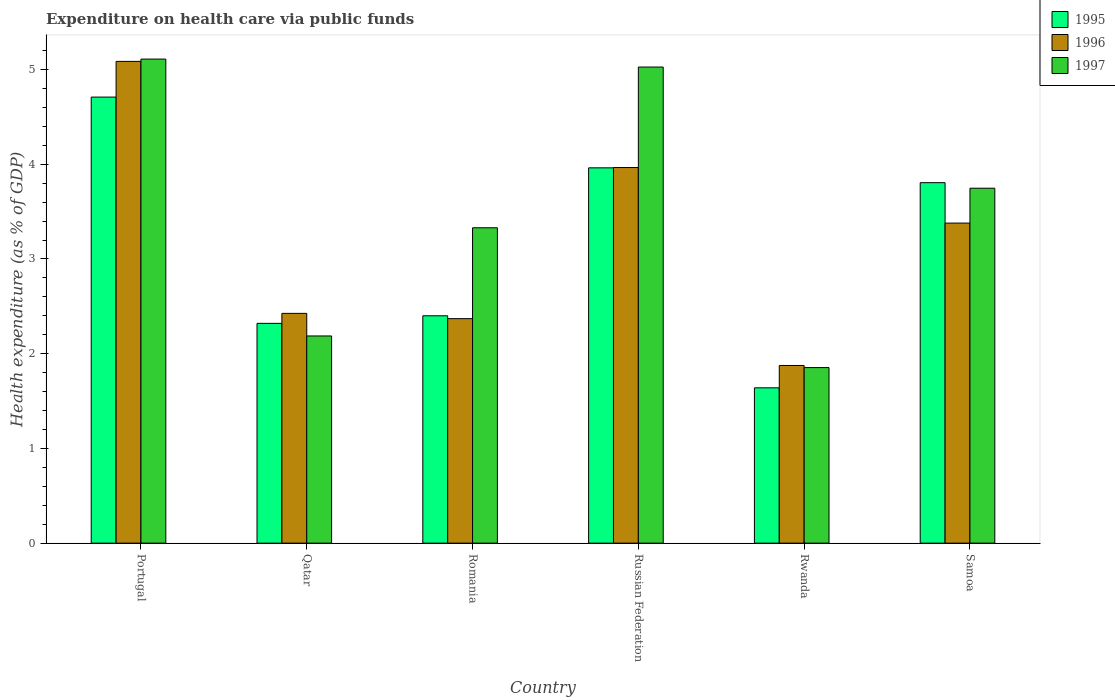How many different coloured bars are there?
Keep it short and to the point. 3. How many groups of bars are there?
Make the answer very short. 6. Are the number of bars on each tick of the X-axis equal?
Keep it short and to the point. Yes. What is the label of the 3rd group of bars from the left?
Offer a terse response. Romania. In how many cases, is the number of bars for a given country not equal to the number of legend labels?
Make the answer very short. 0. What is the expenditure made on health care in 1995 in Portugal?
Give a very brief answer. 4.71. Across all countries, what is the maximum expenditure made on health care in 1996?
Offer a very short reply. 5.09. Across all countries, what is the minimum expenditure made on health care in 1997?
Give a very brief answer. 1.85. In which country was the expenditure made on health care in 1997 maximum?
Your answer should be very brief. Portugal. In which country was the expenditure made on health care in 1997 minimum?
Your response must be concise. Rwanda. What is the total expenditure made on health care in 1997 in the graph?
Your answer should be compact. 21.25. What is the difference between the expenditure made on health care in 1996 in Portugal and that in Romania?
Keep it short and to the point. 2.72. What is the difference between the expenditure made on health care in 1997 in Samoa and the expenditure made on health care in 1995 in Qatar?
Offer a very short reply. 1.43. What is the average expenditure made on health care in 1997 per country?
Make the answer very short. 3.54. What is the difference between the expenditure made on health care of/in 1997 and expenditure made on health care of/in 1995 in Qatar?
Keep it short and to the point. -0.13. What is the ratio of the expenditure made on health care in 1996 in Russian Federation to that in Rwanda?
Your answer should be compact. 2.11. Is the expenditure made on health care in 1997 in Russian Federation less than that in Samoa?
Make the answer very short. No. Is the difference between the expenditure made on health care in 1997 in Russian Federation and Samoa greater than the difference between the expenditure made on health care in 1995 in Russian Federation and Samoa?
Ensure brevity in your answer.  Yes. What is the difference between the highest and the second highest expenditure made on health care in 1996?
Keep it short and to the point. -0.59. What is the difference between the highest and the lowest expenditure made on health care in 1997?
Keep it short and to the point. 3.26. In how many countries, is the expenditure made on health care in 1996 greater than the average expenditure made on health care in 1996 taken over all countries?
Your answer should be compact. 3. What does the 1st bar from the right in Samoa represents?
Your answer should be compact. 1997. How many countries are there in the graph?
Your response must be concise. 6. What is the difference between two consecutive major ticks on the Y-axis?
Keep it short and to the point. 1. Does the graph contain grids?
Your answer should be very brief. No. Where does the legend appear in the graph?
Make the answer very short. Top right. How many legend labels are there?
Offer a terse response. 3. How are the legend labels stacked?
Provide a succinct answer. Vertical. What is the title of the graph?
Provide a succinct answer. Expenditure on health care via public funds. What is the label or title of the X-axis?
Give a very brief answer. Country. What is the label or title of the Y-axis?
Provide a succinct answer. Health expenditure (as % of GDP). What is the Health expenditure (as % of GDP) in 1995 in Portugal?
Your answer should be compact. 4.71. What is the Health expenditure (as % of GDP) of 1996 in Portugal?
Offer a very short reply. 5.09. What is the Health expenditure (as % of GDP) of 1997 in Portugal?
Make the answer very short. 5.11. What is the Health expenditure (as % of GDP) in 1995 in Qatar?
Provide a short and direct response. 2.32. What is the Health expenditure (as % of GDP) of 1996 in Qatar?
Your response must be concise. 2.43. What is the Health expenditure (as % of GDP) in 1997 in Qatar?
Your answer should be compact. 2.19. What is the Health expenditure (as % of GDP) of 1995 in Romania?
Offer a very short reply. 2.4. What is the Health expenditure (as % of GDP) in 1996 in Romania?
Provide a short and direct response. 2.37. What is the Health expenditure (as % of GDP) of 1997 in Romania?
Provide a short and direct response. 3.33. What is the Health expenditure (as % of GDP) of 1995 in Russian Federation?
Make the answer very short. 3.96. What is the Health expenditure (as % of GDP) of 1996 in Russian Federation?
Your response must be concise. 3.97. What is the Health expenditure (as % of GDP) in 1997 in Russian Federation?
Provide a short and direct response. 5.03. What is the Health expenditure (as % of GDP) of 1995 in Rwanda?
Ensure brevity in your answer.  1.64. What is the Health expenditure (as % of GDP) in 1996 in Rwanda?
Provide a short and direct response. 1.88. What is the Health expenditure (as % of GDP) in 1997 in Rwanda?
Offer a very short reply. 1.85. What is the Health expenditure (as % of GDP) in 1995 in Samoa?
Give a very brief answer. 3.81. What is the Health expenditure (as % of GDP) in 1996 in Samoa?
Your response must be concise. 3.38. What is the Health expenditure (as % of GDP) in 1997 in Samoa?
Your answer should be compact. 3.75. Across all countries, what is the maximum Health expenditure (as % of GDP) in 1995?
Give a very brief answer. 4.71. Across all countries, what is the maximum Health expenditure (as % of GDP) in 1996?
Keep it short and to the point. 5.09. Across all countries, what is the maximum Health expenditure (as % of GDP) in 1997?
Provide a short and direct response. 5.11. Across all countries, what is the minimum Health expenditure (as % of GDP) in 1995?
Provide a succinct answer. 1.64. Across all countries, what is the minimum Health expenditure (as % of GDP) in 1996?
Offer a very short reply. 1.88. Across all countries, what is the minimum Health expenditure (as % of GDP) in 1997?
Offer a very short reply. 1.85. What is the total Health expenditure (as % of GDP) of 1995 in the graph?
Provide a short and direct response. 18.84. What is the total Health expenditure (as % of GDP) in 1996 in the graph?
Ensure brevity in your answer.  19.1. What is the total Health expenditure (as % of GDP) in 1997 in the graph?
Your response must be concise. 21.25. What is the difference between the Health expenditure (as % of GDP) in 1995 in Portugal and that in Qatar?
Your answer should be compact. 2.39. What is the difference between the Health expenditure (as % of GDP) of 1996 in Portugal and that in Qatar?
Your answer should be very brief. 2.66. What is the difference between the Health expenditure (as % of GDP) of 1997 in Portugal and that in Qatar?
Provide a short and direct response. 2.92. What is the difference between the Health expenditure (as % of GDP) of 1995 in Portugal and that in Romania?
Offer a terse response. 2.31. What is the difference between the Health expenditure (as % of GDP) in 1996 in Portugal and that in Romania?
Your answer should be very brief. 2.72. What is the difference between the Health expenditure (as % of GDP) in 1997 in Portugal and that in Romania?
Offer a terse response. 1.78. What is the difference between the Health expenditure (as % of GDP) of 1995 in Portugal and that in Russian Federation?
Keep it short and to the point. 0.75. What is the difference between the Health expenditure (as % of GDP) of 1996 in Portugal and that in Russian Federation?
Ensure brevity in your answer.  1.12. What is the difference between the Health expenditure (as % of GDP) in 1997 in Portugal and that in Russian Federation?
Your answer should be very brief. 0.08. What is the difference between the Health expenditure (as % of GDP) of 1995 in Portugal and that in Rwanda?
Give a very brief answer. 3.07. What is the difference between the Health expenditure (as % of GDP) of 1996 in Portugal and that in Rwanda?
Your response must be concise. 3.21. What is the difference between the Health expenditure (as % of GDP) in 1997 in Portugal and that in Rwanda?
Offer a very short reply. 3.26. What is the difference between the Health expenditure (as % of GDP) of 1995 in Portugal and that in Samoa?
Your answer should be very brief. 0.9. What is the difference between the Health expenditure (as % of GDP) in 1996 in Portugal and that in Samoa?
Give a very brief answer. 1.71. What is the difference between the Health expenditure (as % of GDP) of 1997 in Portugal and that in Samoa?
Provide a short and direct response. 1.36. What is the difference between the Health expenditure (as % of GDP) of 1995 in Qatar and that in Romania?
Make the answer very short. -0.08. What is the difference between the Health expenditure (as % of GDP) in 1996 in Qatar and that in Romania?
Provide a short and direct response. 0.06. What is the difference between the Health expenditure (as % of GDP) of 1997 in Qatar and that in Romania?
Your answer should be very brief. -1.14. What is the difference between the Health expenditure (as % of GDP) in 1995 in Qatar and that in Russian Federation?
Keep it short and to the point. -1.64. What is the difference between the Health expenditure (as % of GDP) in 1996 in Qatar and that in Russian Federation?
Provide a succinct answer. -1.54. What is the difference between the Health expenditure (as % of GDP) in 1997 in Qatar and that in Russian Federation?
Keep it short and to the point. -2.84. What is the difference between the Health expenditure (as % of GDP) in 1995 in Qatar and that in Rwanda?
Ensure brevity in your answer.  0.68. What is the difference between the Health expenditure (as % of GDP) in 1996 in Qatar and that in Rwanda?
Make the answer very short. 0.55. What is the difference between the Health expenditure (as % of GDP) of 1997 in Qatar and that in Rwanda?
Provide a short and direct response. 0.33. What is the difference between the Health expenditure (as % of GDP) in 1995 in Qatar and that in Samoa?
Your response must be concise. -1.49. What is the difference between the Health expenditure (as % of GDP) of 1996 in Qatar and that in Samoa?
Provide a succinct answer. -0.95. What is the difference between the Health expenditure (as % of GDP) of 1997 in Qatar and that in Samoa?
Make the answer very short. -1.56. What is the difference between the Health expenditure (as % of GDP) of 1995 in Romania and that in Russian Federation?
Your answer should be very brief. -1.56. What is the difference between the Health expenditure (as % of GDP) of 1996 in Romania and that in Russian Federation?
Keep it short and to the point. -1.6. What is the difference between the Health expenditure (as % of GDP) in 1997 in Romania and that in Russian Federation?
Give a very brief answer. -1.7. What is the difference between the Health expenditure (as % of GDP) in 1995 in Romania and that in Rwanda?
Keep it short and to the point. 0.76. What is the difference between the Health expenditure (as % of GDP) of 1996 in Romania and that in Rwanda?
Provide a short and direct response. 0.49. What is the difference between the Health expenditure (as % of GDP) of 1997 in Romania and that in Rwanda?
Offer a very short reply. 1.48. What is the difference between the Health expenditure (as % of GDP) of 1995 in Romania and that in Samoa?
Make the answer very short. -1.41. What is the difference between the Health expenditure (as % of GDP) in 1996 in Romania and that in Samoa?
Provide a short and direct response. -1.01. What is the difference between the Health expenditure (as % of GDP) of 1997 in Romania and that in Samoa?
Keep it short and to the point. -0.42. What is the difference between the Health expenditure (as % of GDP) in 1995 in Russian Federation and that in Rwanda?
Keep it short and to the point. 2.32. What is the difference between the Health expenditure (as % of GDP) of 1996 in Russian Federation and that in Rwanda?
Your answer should be compact. 2.09. What is the difference between the Health expenditure (as % of GDP) in 1997 in Russian Federation and that in Rwanda?
Keep it short and to the point. 3.17. What is the difference between the Health expenditure (as % of GDP) of 1995 in Russian Federation and that in Samoa?
Make the answer very short. 0.16. What is the difference between the Health expenditure (as % of GDP) in 1996 in Russian Federation and that in Samoa?
Offer a very short reply. 0.59. What is the difference between the Health expenditure (as % of GDP) of 1997 in Russian Federation and that in Samoa?
Make the answer very short. 1.28. What is the difference between the Health expenditure (as % of GDP) of 1995 in Rwanda and that in Samoa?
Keep it short and to the point. -2.17. What is the difference between the Health expenditure (as % of GDP) in 1996 in Rwanda and that in Samoa?
Ensure brevity in your answer.  -1.5. What is the difference between the Health expenditure (as % of GDP) of 1997 in Rwanda and that in Samoa?
Provide a short and direct response. -1.89. What is the difference between the Health expenditure (as % of GDP) in 1995 in Portugal and the Health expenditure (as % of GDP) in 1996 in Qatar?
Keep it short and to the point. 2.28. What is the difference between the Health expenditure (as % of GDP) of 1995 in Portugal and the Health expenditure (as % of GDP) of 1997 in Qatar?
Your answer should be very brief. 2.52. What is the difference between the Health expenditure (as % of GDP) of 1996 in Portugal and the Health expenditure (as % of GDP) of 1997 in Qatar?
Provide a short and direct response. 2.9. What is the difference between the Health expenditure (as % of GDP) in 1995 in Portugal and the Health expenditure (as % of GDP) in 1996 in Romania?
Give a very brief answer. 2.34. What is the difference between the Health expenditure (as % of GDP) of 1995 in Portugal and the Health expenditure (as % of GDP) of 1997 in Romania?
Your response must be concise. 1.38. What is the difference between the Health expenditure (as % of GDP) in 1996 in Portugal and the Health expenditure (as % of GDP) in 1997 in Romania?
Give a very brief answer. 1.76. What is the difference between the Health expenditure (as % of GDP) in 1995 in Portugal and the Health expenditure (as % of GDP) in 1996 in Russian Federation?
Ensure brevity in your answer.  0.74. What is the difference between the Health expenditure (as % of GDP) of 1995 in Portugal and the Health expenditure (as % of GDP) of 1997 in Russian Federation?
Your response must be concise. -0.32. What is the difference between the Health expenditure (as % of GDP) in 1996 in Portugal and the Health expenditure (as % of GDP) in 1997 in Russian Federation?
Make the answer very short. 0.06. What is the difference between the Health expenditure (as % of GDP) in 1995 in Portugal and the Health expenditure (as % of GDP) in 1996 in Rwanda?
Give a very brief answer. 2.83. What is the difference between the Health expenditure (as % of GDP) in 1995 in Portugal and the Health expenditure (as % of GDP) in 1997 in Rwanda?
Offer a very short reply. 2.86. What is the difference between the Health expenditure (as % of GDP) of 1996 in Portugal and the Health expenditure (as % of GDP) of 1997 in Rwanda?
Offer a terse response. 3.23. What is the difference between the Health expenditure (as % of GDP) in 1995 in Portugal and the Health expenditure (as % of GDP) in 1996 in Samoa?
Your answer should be very brief. 1.33. What is the difference between the Health expenditure (as % of GDP) of 1995 in Portugal and the Health expenditure (as % of GDP) of 1997 in Samoa?
Make the answer very short. 0.96. What is the difference between the Health expenditure (as % of GDP) of 1996 in Portugal and the Health expenditure (as % of GDP) of 1997 in Samoa?
Offer a terse response. 1.34. What is the difference between the Health expenditure (as % of GDP) of 1995 in Qatar and the Health expenditure (as % of GDP) of 1996 in Romania?
Ensure brevity in your answer.  -0.05. What is the difference between the Health expenditure (as % of GDP) in 1995 in Qatar and the Health expenditure (as % of GDP) in 1997 in Romania?
Your answer should be very brief. -1.01. What is the difference between the Health expenditure (as % of GDP) in 1996 in Qatar and the Health expenditure (as % of GDP) in 1997 in Romania?
Offer a terse response. -0.9. What is the difference between the Health expenditure (as % of GDP) in 1995 in Qatar and the Health expenditure (as % of GDP) in 1996 in Russian Federation?
Provide a succinct answer. -1.65. What is the difference between the Health expenditure (as % of GDP) of 1995 in Qatar and the Health expenditure (as % of GDP) of 1997 in Russian Federation?
Keep it short and to the point. -2.71. What is the difference between the Health expenditure (as % of GDP) of 1996 in Qatar and the Health expenditure (as % of GDP) of 1997 in Russian Federation?
Offer a very short reply. -2.6. What is the difference between the Health expenditure (as % of GDP) of 1995 in Qatar and the Health expenditure (as % of GDP) of 1996 in Rwanda?
Your answer should be compact. 0.44. What is the difference between the Health expenditure (as % of GDP) of 1995 in Qatar and the Health expenditure (as % of GDP) of 1997 in Rwanda?
Offer a terse response. 0.47. What is the difference between the Health expenditure (as % of GDP) in 1996 in Qatar and the Health expenditure (as % of GDP) in 1997 in Rwanda?
Offer a terse response. 0.57. What is the difference between the Health expenditure (as % of GDP) of 1995 in Qatar and the Health expenditure (as % of GDP) of 1996 in Samoa?
Your answer should be very brief. -1.06. What is the difference between the Health expenditure (as % of GDP) in 1995 in Qatar and the Health expenditure (as % of GDP) in 1997 in Samoa?
Offer a terse response. -1.43. What is the difference between the Health expenditure (as % of GDP) of 1996 in Qatar and the Health expenditure (as % of GDP) of 1997 in Samoa?
Offer a very short reply. -1.32. What is the difference between the Health expenditure (as % of GDP) in 1995 in Romania and the Health expenditure (as % of GDP) in 1996 in Russian Federation?
Offer a very short reply. -1.57. What is the difference between the Health expenditure (as % of GDP) in 1995 in Romania and the Health expenditure (as % of GDP) in 1997 in Russian Federation?
Ensure brevity in your answer.  -2.63. What is the difference between the Health expenditure (as % of GDP) in 1996 in Romania and the Health expenditure (as % of GDP) in 1997 in Russian Federation?
Make the answer very short. -2.66. What is the difference between the Health expenditure (as % of GDP) of 1995 in Romania and the Health expenditure (as % of GDP) of 1996 in Rwanda?
Your answer should be compact. 0.52. What is the difference between the Health expenditure (as % of GDP) in 1995 in Romania and the Health expenditure (as % of GDP) in 1997 in Rwanda?
Your answer should be compact. 0.55. What is the difference between the Health expenditure (as % of GDP) in 1996 in Romania and the Health expenditure (as % of GDP) in 1997 in Rwanda?
Your answer should be compact. 0.52. What is the difference between the Health expenditure (as % of GDP) of 1995 in Romania and the Health expenditure (as % of GDP) of 1996 in Samoa?
Give a very brief answer. -0.98. What is the difference between the Health expenditure (as % of GDP) of 1995 in Romania and the Health expenditure (as % of GDP) of 1997 in Samoa?
Ensure brevity in your answer.  -1.35. What is the difference between the Health expenditure (as % of GDP) of 1996 in Romania and the Health expenditure (as % of GDP) of 1997 in Samoa?
Provide a short and direct response. -1.38. What is the difference between the Health expenditure (as % of GDP) of 1995 in Russian Federation and the Health expenditure (as % of GDP) of 1996 in Rwanda?
Give a very brief answer. 2.09. What is the difference between the Health expenditure (as % of GDP) of 1995 in Russian Federation and the Health expenditure (as % of GDP) of 1997 in Rwanda?
Your answer should be very brief. 2.11. What is the difference between the Health expenditure (as % of GDP) in 1996 in Russian Federation and the Health expenditure (as % of GDP) in 1997 in Rwanda?
Make the answer very short. 2.11. What is the difference between the Health expenditure (as % of GDP) of 1995 in Russian Federation and the Health expenditure (as % of GDP) of 1996 in Samoa?
Offer a very short reply. 0.58. What is the difference between the Health expenditure (as % of GDP) in 1995 in Russian Federation and the Health expenditure (as % of GDP) in 1997 in Samoa?
Offer a terse response. 0.21. What is the difference between the Health expenditure (as % of GDP) in 1996 in Russian Federation and the Health expenditure (as % of GDP) in 1997 in Samoa?
Your response must be concise. 0.22. What is the difference between the Health expenditure (as % of GDP) of 1995 in Rwanda and the Health expenditure (as % of GDP) of 1996 in Samoa?
Keep it short and to the point. -1.74. What is the difference between the Health expenditure (as % of GDP) in 1995 in Rwanda and the Health expenditure (as % of GDP) in 1997 in Samoa?
Your response must be concise. -2.11. What is the difference between the Health expenditure (as % of GDP) of 1996 in Rwanda and the Health expenditure (as % of GDP) of 1997 in Samoa?
Keep it short and to the point. -1.87. What is the average Health expenditure (as % of GDP) of 1995 per country?
Offer a terse response. 3.14. What is the average Health expenditure (as % of GDP) of 1996 per country?
Your answer should be very brief. 3.18. What is the average Health expenditure (as % of GDP) in 1997 per country?
Offer a terse response. 3.54. What is the difference between the Health expenditure (as % of GDP) of 1995 and Health expenditure (as % of GDP) of 1996 in Portugal?
Keep it short and to the point. -0.38. What is the difference between the Health expenditure (as % of GDP) of 1995 and Health expenditure (as % of GDP) of 1997 in Portugal?
Offer a terse response. -0.4. What is the difference between the Health expenditure (as % of GDP) of 1996 and Health expenditure (as % of GDP) of 1997 in Portugal?
Give a very brief answer. -0.02. What is the difference between the Health expenditure (as % of GDP) of 1995 and Health expenditure (as % of GDP) of 1996 in Qatar?
Provide a short and direct response. -0.11. What is the difference between the Health expenditure (as % of GDP) of 1995 and Health expenditure (as % of GDP) of 1997 in Qatar?
Ensure brevity in your answer.  0.13. What is the difference between the Health expenditure (as % of GDP) in 1996 and Health expenditure (as % of GDP) in 1997 in Qatar?
Give a very brief answer. 0.24. What is the difference between the Health expenditure (as % of GDP) of 1995 and Health expenditure (as % of GDP) of 1996 in Romania?
Provide a succinct answer. 0.03. What is the difference between the Health expenditure (as % of GDP) in 1995 and Health expenditure (as % of GDP) in 1997 in Romania?
Ensure brevity in your answer.  -0.93. What is the difference between the Health expenditure (as % of GDP) in 1996 and Health expenditure (as % of GDP) in 1997 in Romania?
Your answer should be compact. -0.96. What is the difference between the Health expenditure (as % of GDP) in 1995 and Health expenditure (as % of GDP) in 1996 in Russian Federation?
Make the answer very short. -0. What is the difference between the Health expenditure (as % of GDP) of 1995 and Health expenditure (as % of GDP) of 1997 in Russian Federation?
Make the answer very short. -1.06. What is the difference between the Health expenditure (as % of GDP) in 1996 and Health expenditure (as % of GDP) in 1997 in Russian Federation?
Provide a succinct answer. -1.06. What is the difference between the Health expenditure (as % of GDP) of 1995 and Health expenditure (as % of GDP) of 1996 in Rwanda?
Your answer should be compact. -0.24. What is the difference between the Health expenditure (as % of GDP) in 1995 and Health expenditure (as % of GDP) in 1997 in Rwanda?
Offer a terse response. -0.21. What is the difference between the Health expenditure (as % of GDP) in 1996 and Health expenditure (as % of GDP) in 1997 in Rwanda?
Provide a short and direct response. 0.02. What is the difference between the Health expenditure (as % of GDP) in 1995 and Health expenditure (as % of GDP) in 1996 in Samoa?
Ensure brevity in your answer.  0.43. What is the difference between the Health expenditure (as % of GDP) of 1995 and Health expenditure (as % of GDP) of 1997 in Samoa?
Make the answer very short. 0.06. What is the difference between the Health expenditure (as % of GDP) in 1996 and Health expenditure (as % of GDP) in 1997 in Samoa?
Make the answer very short. -0.37. What is the ratio of the Health expenditure (as % of GDP) in 1995 in Portugal to that in Qatar?
Give a very brief answer. 2.03. What is the ratio of the Health expenditure (as % of GDP) of 1996 in Portugal to that in Qatar?
Provide a succinct answer. 2.1. What is the ratio of the Health expenditure (as % of GDP) in 1997 in Portugal to that in Qatar?
Your response must be concise. 2.34. What is the ratio of the Health expenditure (as % of GDP) of 1995 in Portugal to that in Romania?
Offer a terse response. 1.96. What is the ratio of the Health expenditure (as % of GDP) of 1996 in Portugal to that in Romania?
Give a very brief answer. 2.15. What is the ratio of the Health expenditure (as % of GDP) of 1997 in Portugal to that in Romania?
Your response must be concise. 1.53. What is the ratio of the Health expenditure (as % of GDP) in 1995 in Portugal to that in Russian Federation?
Ensure brevity in your answer.  1.19. What is the ratio of the Health expenditure (as % of GDP) of 1996 in Portugal to that in Russian Federation?
Your answer should be very brief. 1.28. What is the ratio of the Health expenditure (as % of GDP) of 1997 in Portugal to that in Russian Federation?
Your answer should be very brief. 1.02. What is the ratio of the Health expenditure (as % of GDP) of 1995 in Portugal to that in Rwanda?
Provide a succinct answer. 2.87. What is the ratio of the Health expenditure (as % of GDP) of 1996 in Portugal to that in Rwanda?
Keep it short and to the point. 2.71. What is the ratio of the Health expenditure (as % of GDP) of 1997 in Portugal to that in Rwanda?
Provide a short and direct response. 2.76. What is the ratio of the Health expenditure (as % of GDP) in 1995 in Portugal to that in Samoa?
Provide a short and direct response. 1.24. What is the ratio of the Health expenditure (as % of GDP) in 1996 in Portugal to that in Samoa?
Keep it short and to the point. 1.51. What is the ratio of the Health expenditure (as % of GDP) of 1997 in Portugal to that in Samoa?
Ensure brevity in your answer.  1.36. What is the ratio of the Health expenditure (as % of GDP) of 1995 in Qatar to that in Romania?
Your response must be concise. 0.97. What is the ratio of the Health expenditure (as % of GDP) in 1996 in Qatar to that in Romania?
Your answer should be very brief. 1.02. What is the ratio of the Health expenditure (as % of GDP) in 1997 in Qatar to that in Romania?
Keep it short and to the point. 0.66. What is the ratio of the Health expenditure (as % of GDP) in 1995 in Qatar to that in Russian Federation?
Offer a terse response. 0.59. What is the ratio of the Health expenditure (as % of GDP) of 1996 in Qatar to that in Russian Federation?
Your answer should be compact. 0.61. What is the ratio of the Health expenditure (as % of GDP) in 1997 in Qatar to that in Russian Federation?
Offer a terse response. 0.44. What is the ratio of the Health expenditure (as % of GDP) in 1995 in Qatar to that in Rwanda?
Ensure brevity in your answer.  1.42. What is the ratio of the Health expenditure (as % of GDP) of 1996 in Qatar to that in Rwanda?
Your answer should be very brief. 1.29. What is the ratio of the Health expenditure (as % of GDP) of 1997 in Qatar to that in Rwanda?
Offer a terse response. 1.18. What is the ratio of the Health expenditure (as % of GDP) in 1995 in Qatar to that in Samoa?
Make the answer very short. 0.61. What is the ratio of the Health expenditure (as % of GDP) in 1996 in Qatar to that in Samoa?
Give a very brief answer. 0.72. What is the ratio of the Health expenditure (as % of GDP) of 1997 in Qatar to that in Samoa?
Your answer should be compact. 0.58. What is the ratio of the Health expenditure (as % of GDP) in 1995 in Romania to that in Russian Federation?
Your answer should be very brief. 0.61. What is the ratio of the Health expenditure (as % of GDP) of 1996 in Romania to that in Russian Federation?
Give a very brief answer. 0.6. What is the ratio of the Health expenditure (as % of GDP) of 1997 in Romania to that in Russian Federation?
Make the answer very short. 0.66. What is the ratio of the Health expenditure (as % of GDP) in 1995 in Romania to that in Rwanda?
Provide a succinct answer. 1.46. What is the ratio of the Health expenditure (as % of GDP) of 1996 in Romania to that in Rwanda?
Provide a short and direct response. 1.26. What is the ratio of the Health expenditure (as % of GDP) in 1997 in Romania to that in Rwanda?
Make the answer very short. 1.8. What is the ratio of the Health expenditure (as % of GDP) in 1995 in Romania to that in Samoa?
Your answer should be very brief. 0.63. What is the ratio of the Health expenditure (as % of GDP) of 1996 in Romania to that in Samoa?
Keep it short and to the point. 0.7. What is the ratio of the Health expenditure (as % of GDP) of 1997 in Romania to that in Samoa?
Offer a very short reply. 0.89. What is the ratio of the Health expenditure (as % of GDP) in 1995 in Russian Federation to that in Rwanda?
Your answer should be very brief. 2.42. What is the ratio of the Health expenditure (as % of GDP) in 1996 in Russian Federation to that in Rwanda?
Your answer should be very brief. 2.11. What is the ratio of the Health expenditure (as % of GDP) of 1997 in Russian Federation to that in Rwanda?
Provide a succinct answer. 2.71. What is the ratio of the Health expenditure (as % of GDP) of 1995 in Russian Federation to that in Samoa?
Your answer should be compact. 1.04. What is the ratio of the Health expenditure (as % of GDP) of 1996 in Russian Federation to that in Samoa?
Provide a succinct answer. 1.17. What is the ratio of the Health expenditure (as % of GDP) of 1997 in Russian Federation to that in Samoa?
Provide a short and direct response. 1.34. What is the ratio of the Health expenditure (as % of GDP) of 1995 in Rwanda to that in Samoa?
Make the answer very short. 0.43. What is the ratio of the Health expenditure (as % of GDP) in 1996 in Rwanda to that in Samoa?
Your answer should be compact. 0.56. What is the ratio of the Health expenditure (as % of GDP) of 1997 in Rwanda to that in Samoa?
Keep it short and to the point. 0.49. What is the difference between the highest and the second highest Health expenditure (as % of GDP) in 1995?
Ensure brevity in your answer.  0.75. What is the difference between the highest and the second highest Health expenditure (as % of GDP) in 1996?
Offer a very short reply. 1.12. What is the difference between the highest and the second highest Health expenditure (as % of GDP) in 1997?
Keep it short and to the point. 0.08. What is the difference between the highest and the lowest Health expenditure (as % of GDP) of 1995?
Your answer should be compact. 3.07. What is the difference between the highest and the lowest Health expenditure (as % of GDP) in 1996?
Offer a terse response. 3.21. What is the difference between the highest and the lowest Health expenditure (as % of GDP) in 1997?
Provide a short and direct response. 3.26. 